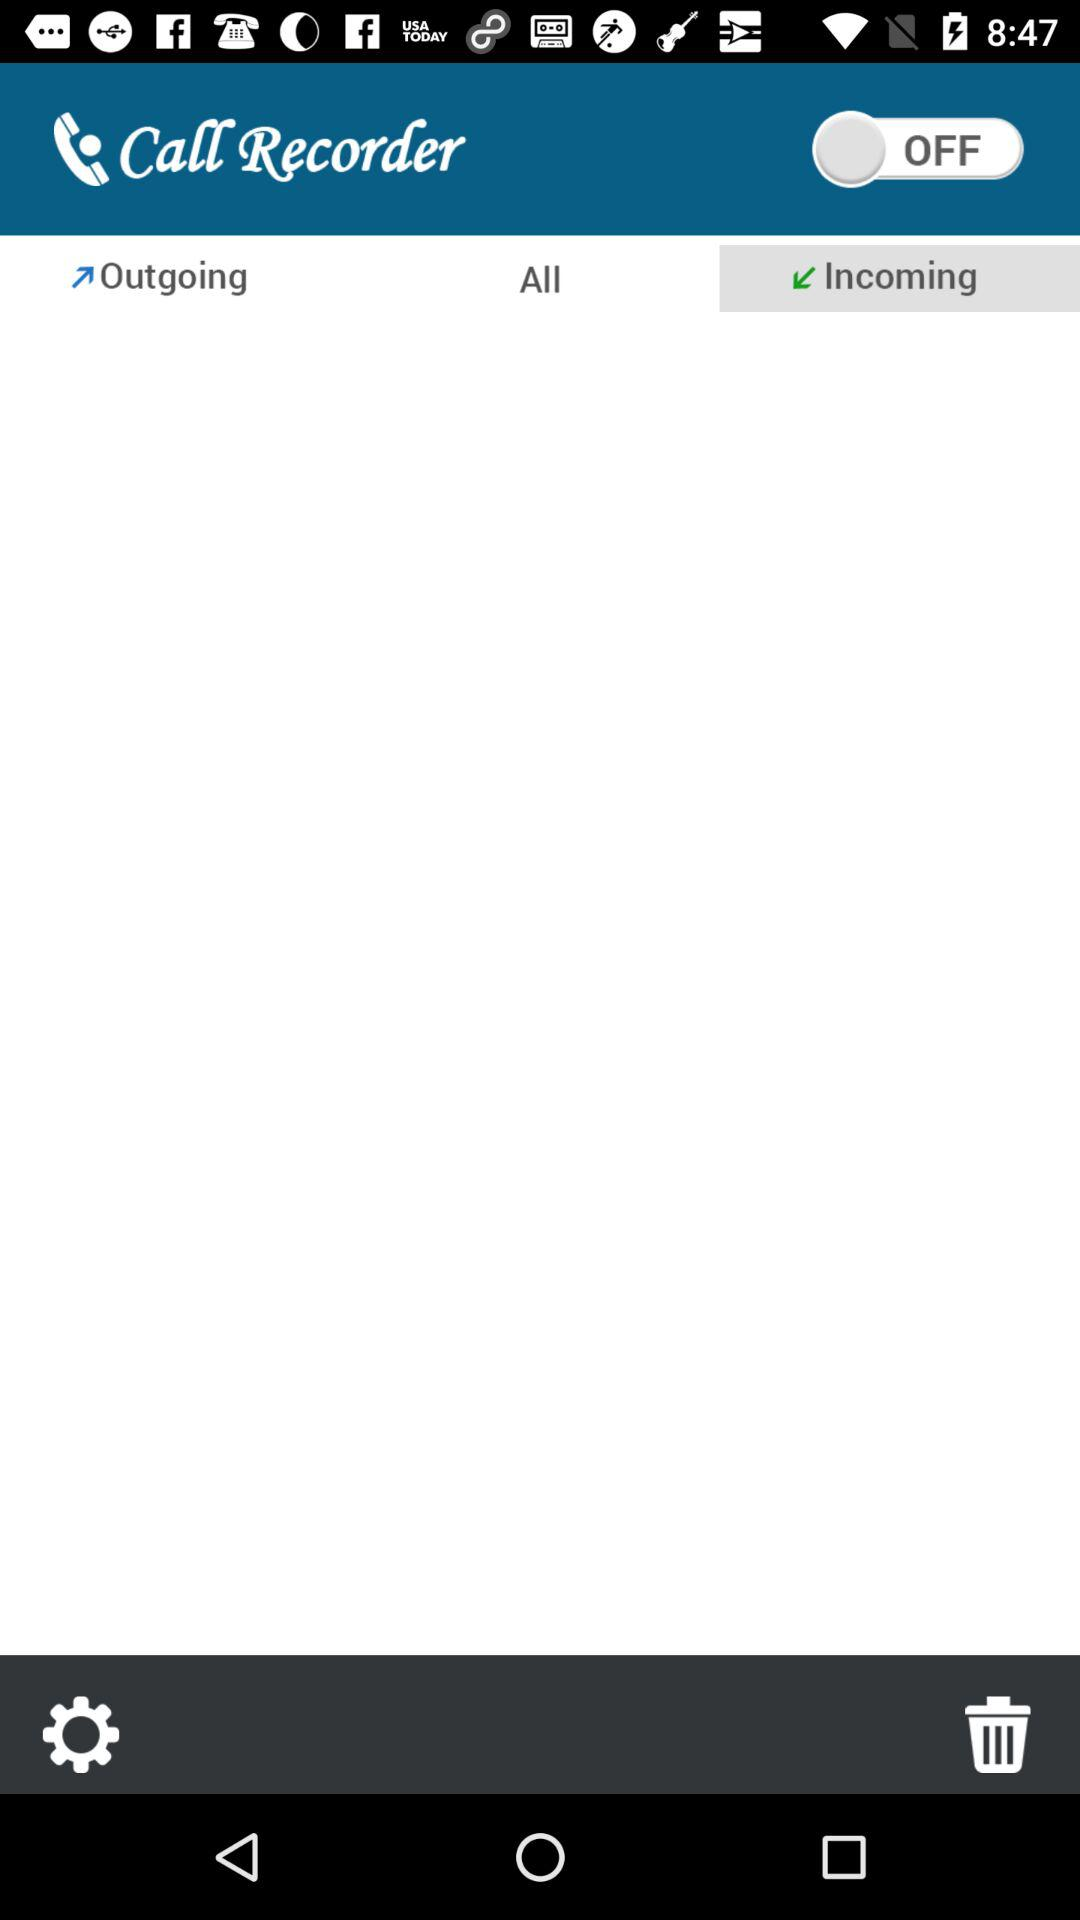What tab is selected? The selected tab is "Incoming". 